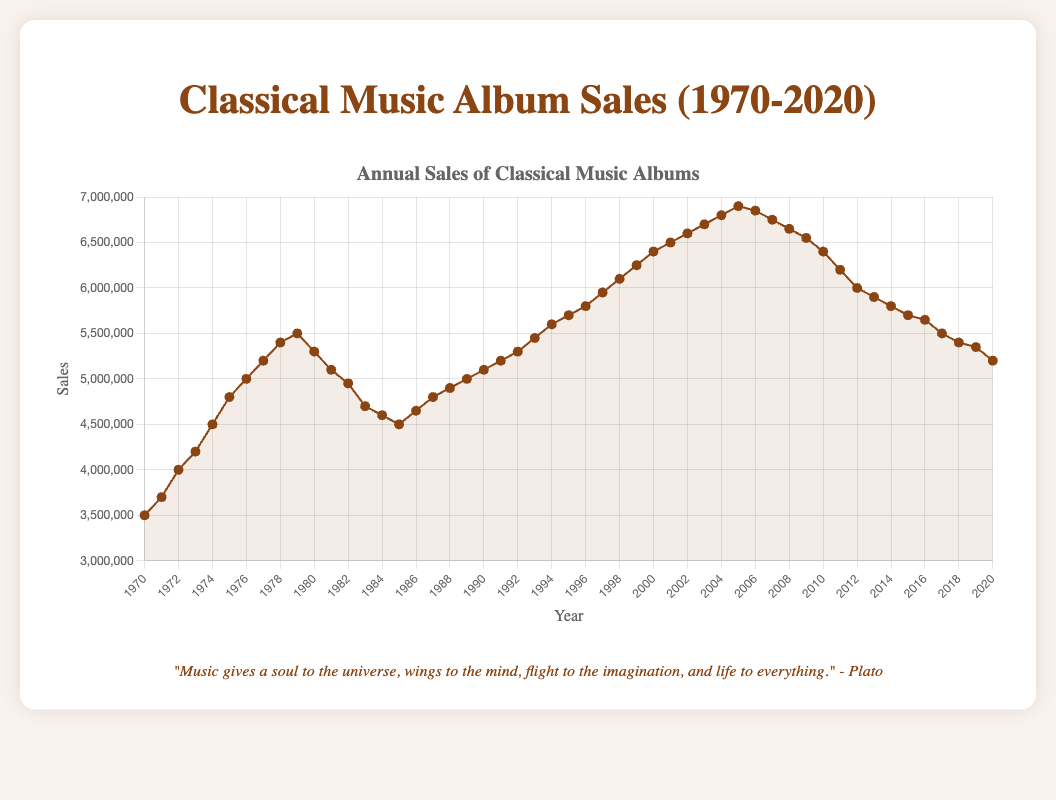What was the highest annual sales value and in what year did it occur? The highest sales value can be found by identifying the peak in the line plot. By examining the data, 2005 had the highest annual sales of 6.9 million albums.
Answer: 2005, 6.9 million During which decade did classical music album sales decline the most? To determine the decade with the greatest decline, observe the trend of the sales line plot each decade. The largest decline is observed from 2000 to 2010, where sales decreased from 6.9 million to 6.4 million.
Answer: 2000-2010 Which year had the lowest annual sales of classical music albums in the 1980s? To find the lowest annual sales in the 1980s, review sales data for each year in the decade. The lowest sales occur in 1985, with 4.5 million albums sold.
Answer: 1985 Calculate the average annual sales of classical music albums in the year 2000s (2000-2009). Sum up the annual sales from 2000 to 2009 and then divide by the number of years (10 years). (6.4 + 6.5 + 6.6 + 6.7 + 6.8 + 6.9 + 6.85 + 6.75 + 6.65 + 6.55) / 10 = 6.715 million
Answer: 6.715 million From 1970 to 2020, was there a continuous 5-year period where annual sales consistently increased? If so, identify the period. Check for any 5 consecutive years where sales increase each year. From 1971 (3.7 million) to 1975 (4.8 million) there is a continuous increase observed.
Answer: 1971-1975 Compare annual sales between 1990 and 2000. By what percentage did sales increase during this period? Calculate percentage increase using the formula: ((Sales in 2000 - Sales in 1990) / Sales in 1990) * 100. ((6.4 million - 5.1 million) / 5.1 million) * 100 ≈ 25.49%.
Answer: ≈ 25.49% In which year did classical music album sales return to approximately the same level as in 1970? Compare the sales in each year to the sales in 1970 (3.5 million). The sales in 1985 were exactly 4.5 million, nearing the sales in 1974. However, 1970 levels are closely matched by 2017-2020, particularly 2020 at 5.2 million.
Answer: 2020 What is the difference in sales between the year with the highest sales and the year with the lowest sales within the dataset? Highest sales (2005 at 6.9 million) - Lowest sales (1970 at 3.5 million). 6.9 million - 3.5 million = 3.4 million.
Answer: 3.4 million Identify and compare the sales trend in the 1990s to the 2010s. Did sales increase, decrease, or stay relatively stable? Examine the sales trend line from 1990 to 1999 and 2010 to 2019. The 1990s show a general increase, while the 2010s exhibit a steady decline.
Answer: 1990s: Increase, 2010s: Decrease 